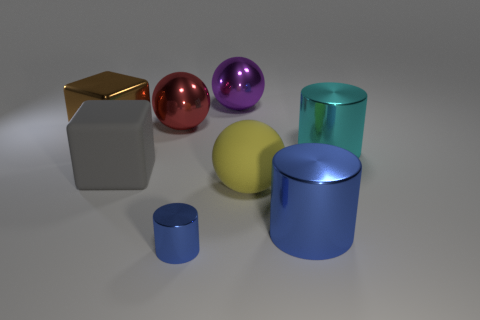Add 1 large gray rubber things. How many objects exist? 9 Subtract all spheres. How many objects are left? 5 Add 2 big matte balls. How many big matte balls are left? 3 Add 7 metal blocks. How many metal blocks exist? 8 Subtract 0 yellow cubes. How many objects are left? 8 Subtract all purple metal spheres. Subtract all tiny cylinders. How many objects are left? 6 